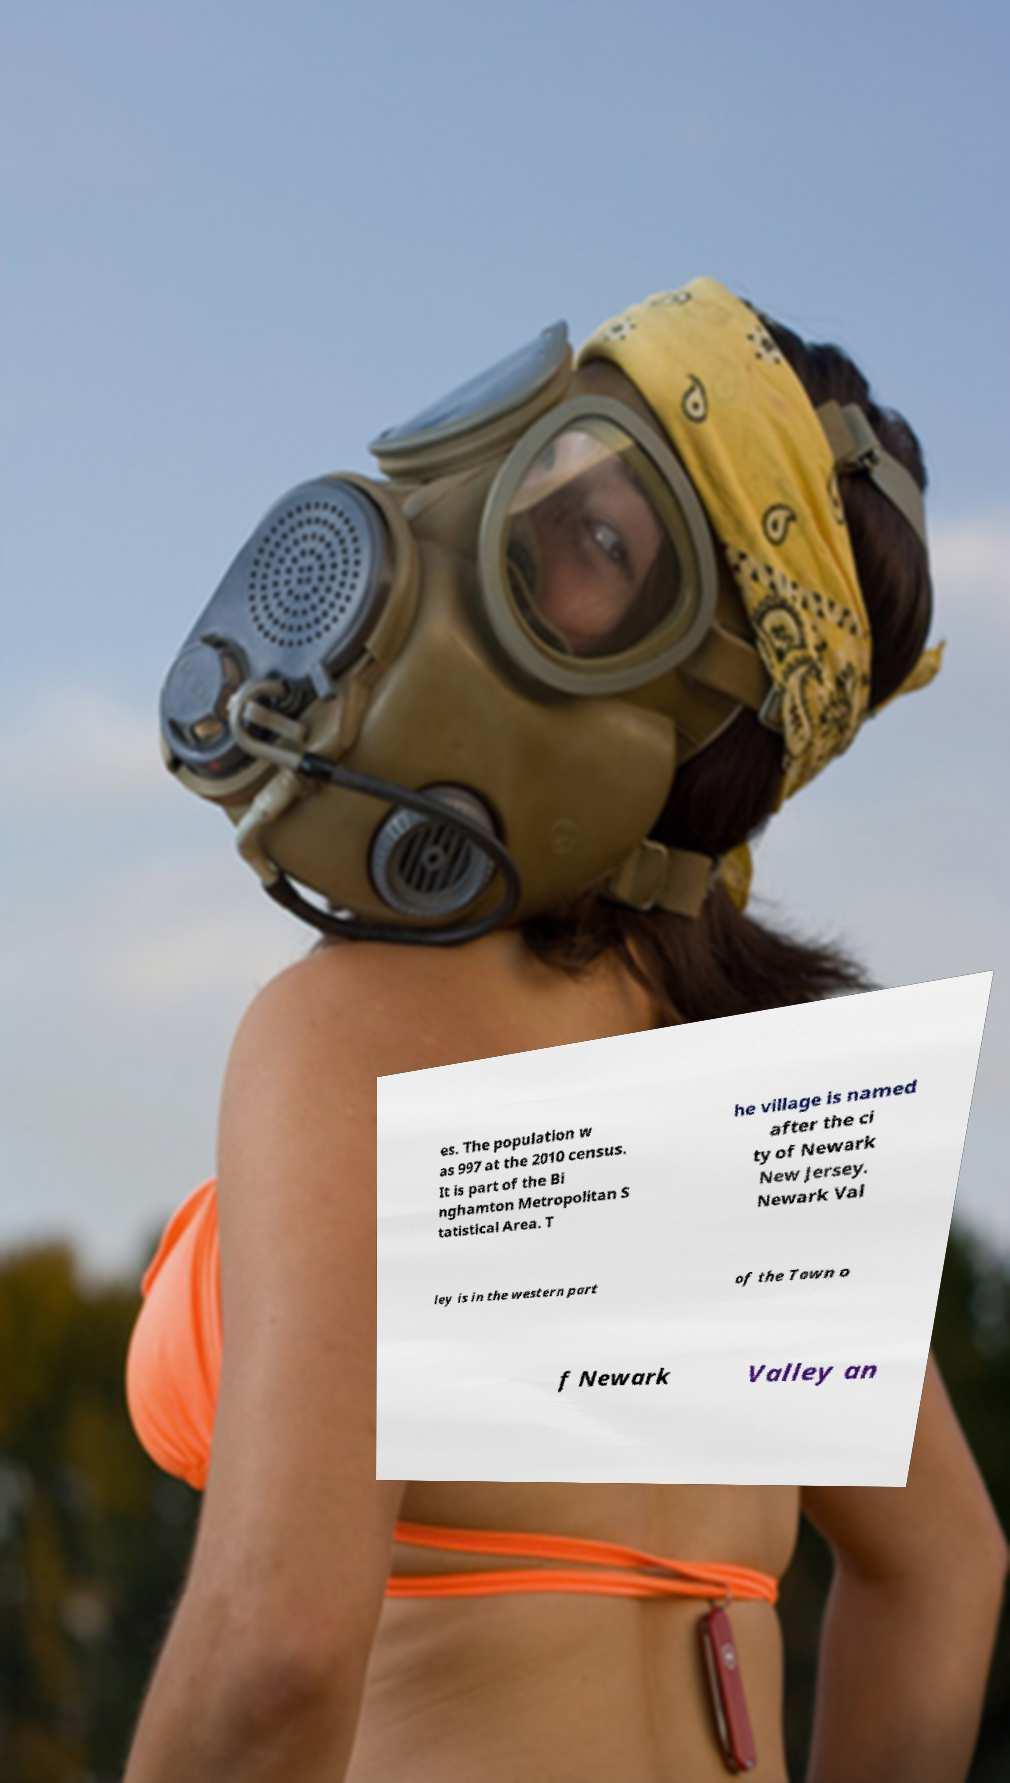Can you read and provide the text displayed in the image?This photo seems to have some interesting text. Can you extract and type it out for me? es. The population w as 997 at the 2010 census. It is part of the Bi nghamton Metropolitan S tatistical Area. T he village is named after the ci ty of Newark New Jersey. Newark Val ley is in the western part of the Town o f Newark Valley an 